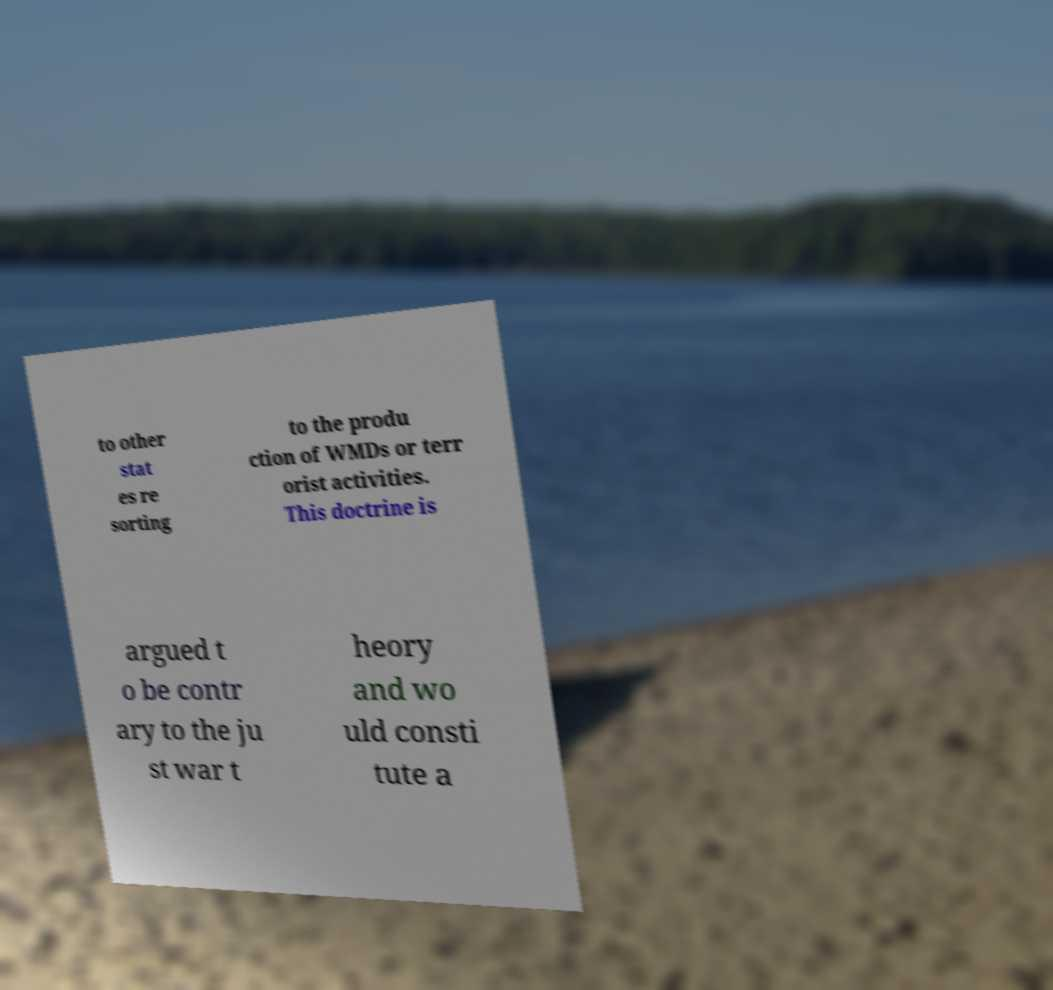Can you read and provide the text displayed in the image?This photo seems to have some interesting text. Can you extract and type it out for me? to other stat es re sorting to the produ ction of WMDs or terr orist activities. This doctrine is argued t o be contr ary to the ju st war t heory and wo uld consti tute a 